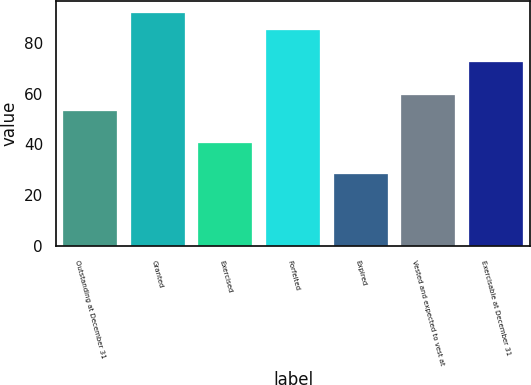Convert chart. <chart><loc_0><loc_0><loc_500><loc_500><bar_chart><fcel>Outstanding at December 31<fcel>Granted<fcel>Exercised<fcel>Forfeited<fcel>Expired<fcel>Vested and expected to vest at<fcel>Exercisable at December 31<nl><fcel>53.24<fcel>91.72<fcel>40.58<fcel>84.89<fcel>28.38<fcel>59.57<fcel>72.23<nl></chart> 